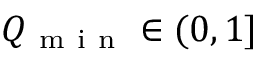<formula> <loc_0><loc_0><loc_500><loc_500>Q _ { m i n } \in ( 0 , 1 ]</formula> 